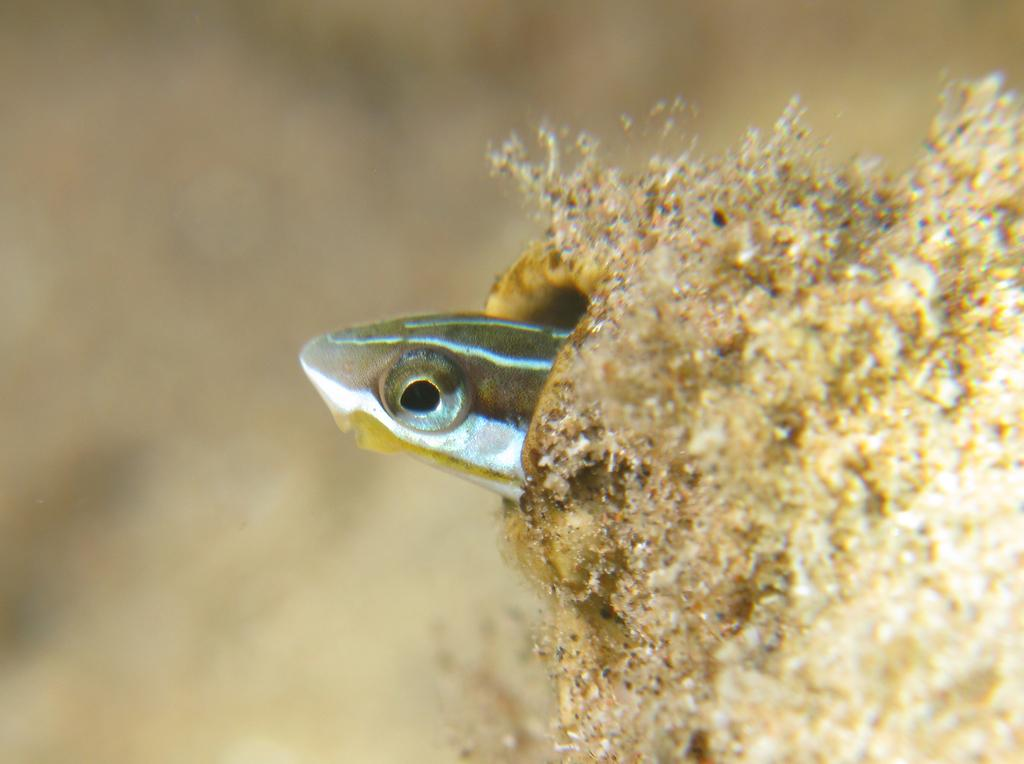What type of animal is present in the image? There is an amphibian in the image. What is the amphibian doing in the image? The amphibian is looking out from a hole. How many eyes of the amphibian can be seen in the image? One eye of the amphibian is visible. What is the purpose of the stick in the image? There is no stick present in the image. Is the image a work of fiction or non-fiction? The image itself is neither fiction nor non-fiction; it is a photograph or illustration. 